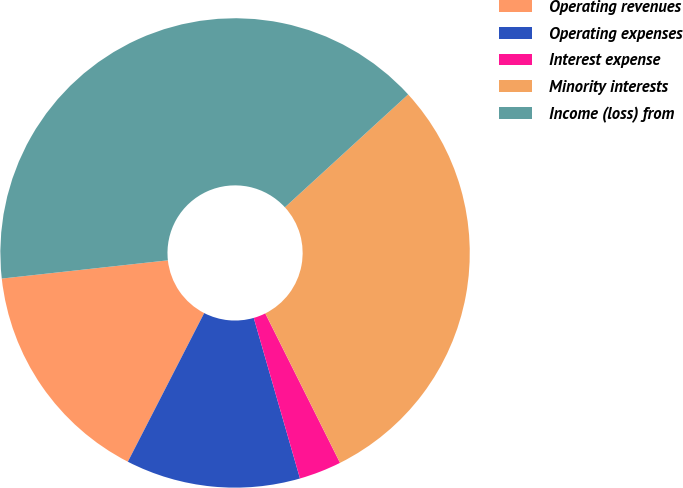Convert chart to OTSL. <chart><loc_0><loc_0><loc_500><loc_500><pie_chart><fcel>Operating revenues<fcel>Operating expenses<fcel>Interest expense<fcel>Minority interests<fcel>Income (loss) from<nl><fcel>15.71%<fcel>12.01%<fcel>2.92%<fcel>29.42%<fcel>39.94%<nl></chart> 